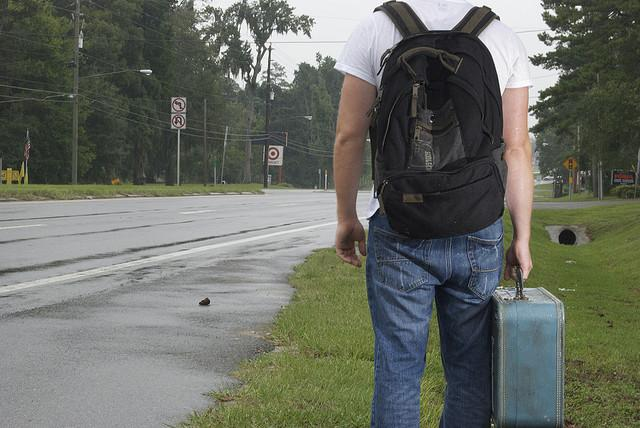What sign is on right side of the road?

Choices:
A) signal
B) slow
C) slow
D) stop signal 